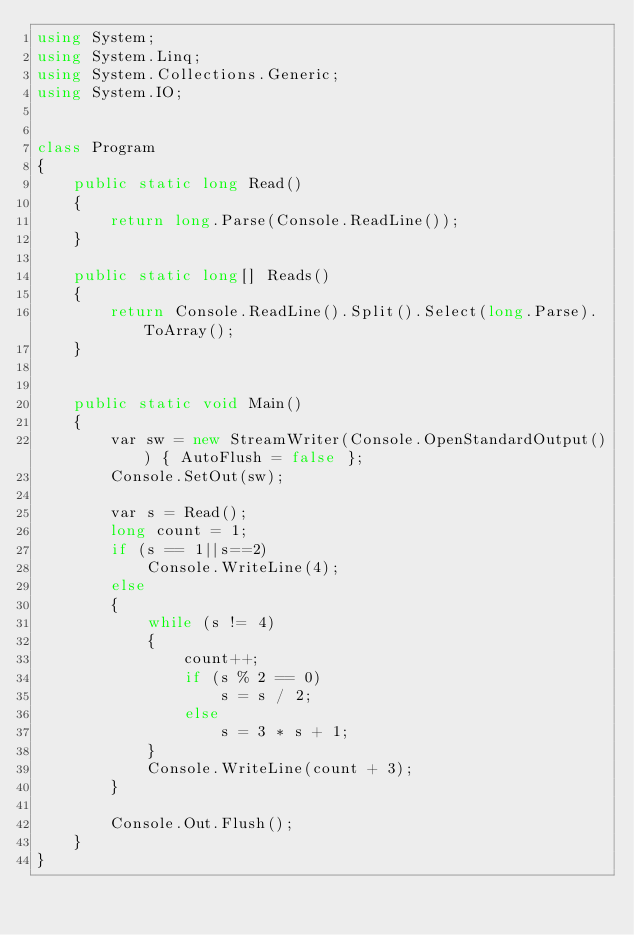Convert code to text. <code><loc_0><loc_0><loc_500><loc_500><_C#_>using System;
using System.Linq;
using System.Collections.Generic;
using System.IO;


class Program
{
    public static long Read()
    {
        return long.Parse(Console.ReadLine());
    }

    public static long[] Reads()
    {
        return Console.ReadLine().Split().Select(long.Parse).ToArray();
    }

   
    public static void Main()
    {
        var sw = new StreamWriter(Console.OpenStandardOutput()) { AutoFlush = false };
        Console.SetOut(sw);

        var s = Read();
        long count = 1;
        if (s == 1||s==2)
            Console.WriteLine(4);
        else
        {
            while (s != 4)
            {
                count++;
                if (s % 2 == 0)
                    s = s / 2;
                else
                    s = 3 * s + 1;
            }
            Console.WriteLine(count + 3);
        }

        Console.Out.Flush();
    }
}</code> 